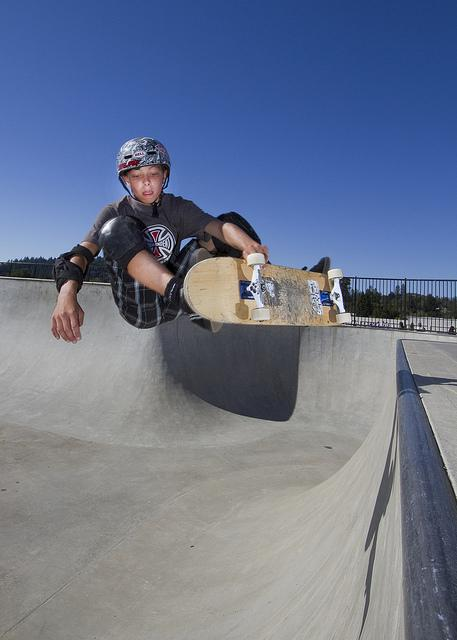Why is his head covered? protection 